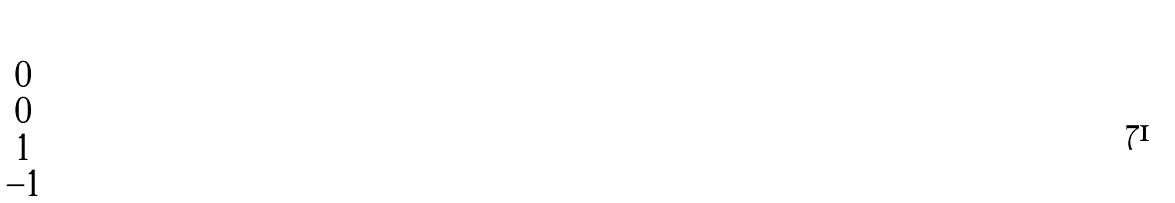Convert formula to latex. <formula><loc_0><loc_0><loc_500><loc_500>\begin{pmatrix} 0 \\ 0 \\ 1 \\ - 1 \end{pmatrix}</formula> 